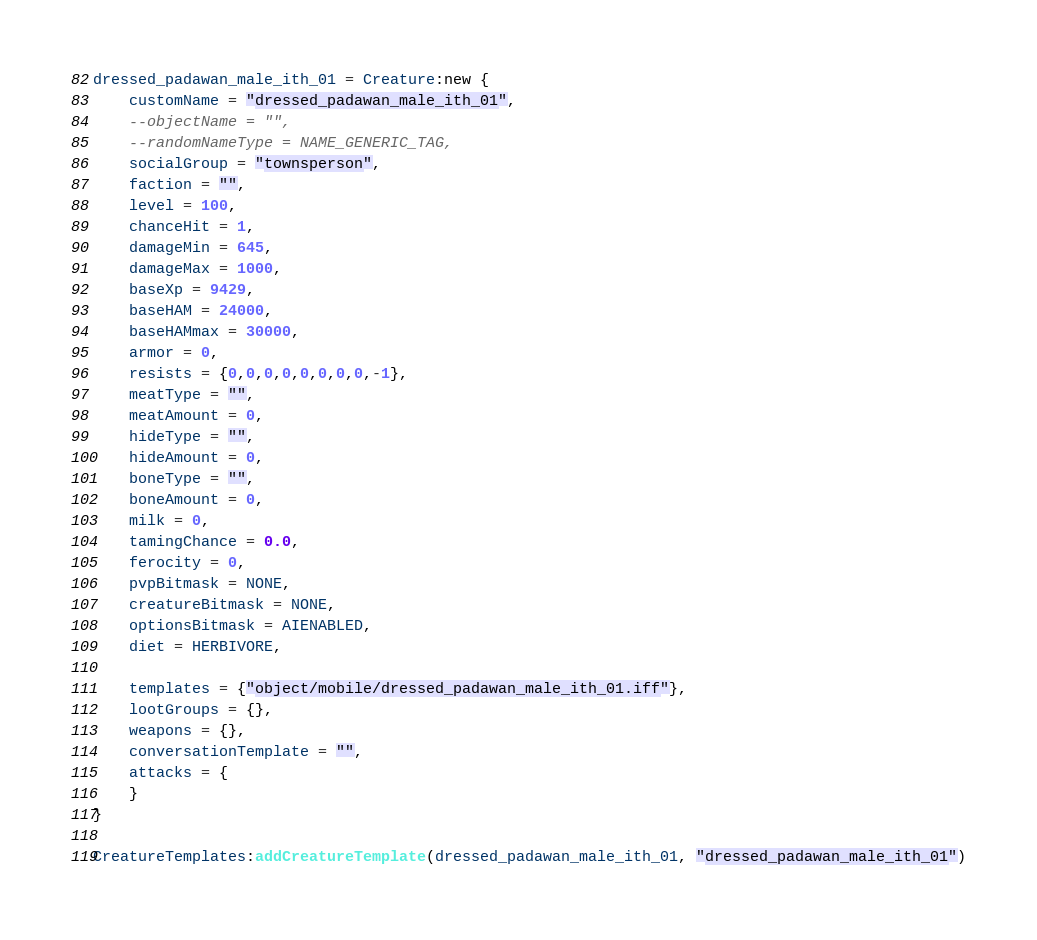Convert code to text. <code><loc_0><loc_0><loc_500><loc_500><_Lua_>dressed_padawan_male_ith_01 = Creature:new {
	customName = "dressed_padawan_male_ith_01",
	--objectName = "",
	--randomNameType = NAME_GENERIC_TAG,
	socialGroup = "townsperson",
	faction = "",
	level = 100,
	chanceHit = 1,
	damageMin = 645,
	damageMax = 1000,
	baseXp = 9429,
	baseHAM = 24000,
	baseHAMmax = 30000,
	armor = 0,
	resists = {0,0,0,0,0,0,0,0,-1},
	meatType = "",
	meatAmount = 0,
	hideType = "",
	hideAmount = 0,
	boneType = "",
	boneAmount = 0,
	milk = 0,
	tamingChance = 0.0,
	ferocity = 0,
	pvpBitmask = NONE,
	creatureBitmask = NONE,
	optionsBitmask = AIENABLED,
	diet = HERBIVORE,

	templates = {"object/mobile/dressed_padawan_male_ith_01.iff"},
	lootGroups = {},
	weapons = {},
	conversationTemplate = "",
	attacks = {
	}
}

CreatureTemplates:addCreatureTemplate(dressed_padawan_male_ith_01, "dressed_padawan_male_ith_01")

</code> 